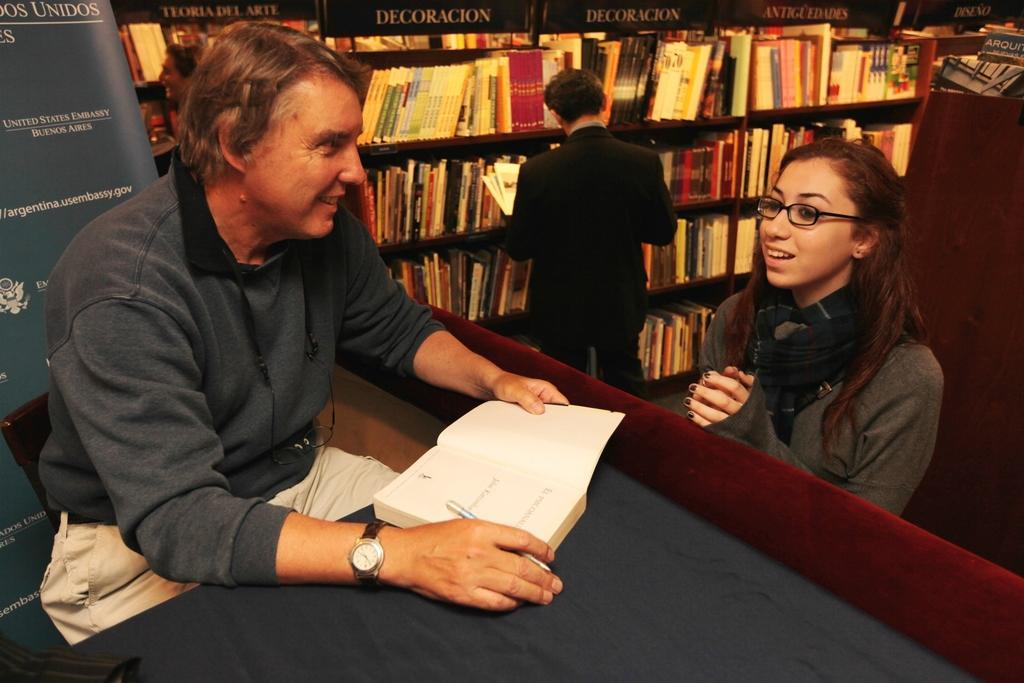In one or two sentences, can you explain what this image depicts? This picture is clicked inside the room. On the left there is a person sitting and holding a book. On the right we can see the two persons standing on the ground and we can see the table, banners on which we can see the text. In the background we can see the cabinets containing many number of books and we can see the text on the cabinets. 